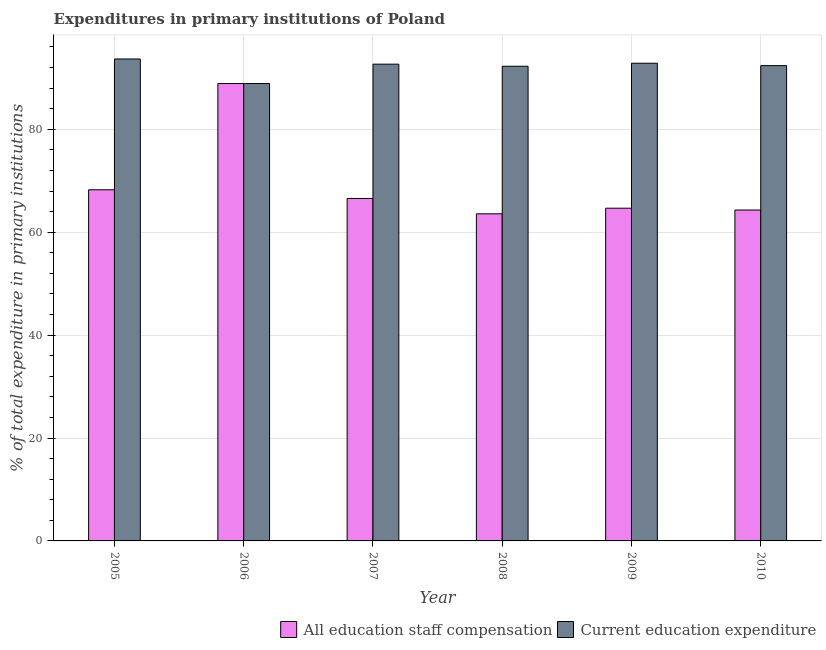Are the number of bars on each tick of the X-axis equal?
Your answer should be very brief. Yes. How many bars are there on the 6th tick from the left?
Offer a very short reply. 2. How many bars are there on the 4th tick from the right?
Provide a succinct answer. 2. What is the label of the 3rd group of bars from the left?
Keep it short and to the point. 2007. What is the expenditure in education in 2009?
Give a very brief answer. 92.84. Across all years, what is the maximum expenditure in staff compensation?
Provide a short and direct response. 88.89. Across all years, what is the minimum expenditure in education?
Give a very brief answer. 88.89. What is the total expenditure in education in the graph?
Give a very brief answer. 552.68. What is the difference between the expenditure in education in 2008 and that in 2010?
Your answer should be compact. -0.12. What is the difference between the expenditure in education in 2009 and the expenditure in staff compensation in 2007?
Make the answer very short. 0.18. What is the average expenditure in staff compensation per year?
Offer a terse response. 69.37. In the year 2005, what is the difference between the expenditure in education and expenditure in staff compensation?
Offer a terse response. 0. In how many years, is the expenditure in staff compensation greater than 24 %?
Offer a terse response. 6. What is the ratio of the expenditure in staff compensation in 2005 to that in 2010?
Offer a terse response. 1.06. Is the expenditure in education in 2005 less than that in 2009?
Offer a very short reply. No. Is the difference between the expenditure in education in 2006 and 2010 greater than the difference between the expenditure in staff compensation in 2006 and 2010?
Give a very brief answer. No. What is the difference between the highest and the second highest expenditure in staff compensation?
Give a very brief answer. 20.65. What is the difference between the highest and the lowest expenditure in staff compensation?
Provide a succinct answer. 25.32. What does the 2nd bar from the left in 2007 represents?
Ensure brevity in your answer.  Current education expenditure. What does the 2nd bar from the right in 2007 represents?
Keep it short and to the point. All education staff compensation. How many years are there in the graph?
Make the answer very short. 6. Does the graph contain any zero values?
Offer a terse response. No. Does the graph contain grids?
Keep it short and to the point. Yes. How are the legend labels stacked?
Offer a very short reply. Horizontal. What is the title of the graph?
Make the answer very short. Expenditures in primary institutions of Poland. Does "Secondary school" appear as one of the legend labels in the graph?
Keep it short and to the point. No. What is the label or title of the X-axis?
Your response must be concise. Year. What is the label or title of the Y-axis?
Make the answer very short. % of total expenditure in primary institutions. What is the % of total expenditure in primary institutions of All education staff compensation in 2005?
Provide a succinct answer. 68.25. What is the % of total expenditure in primary institutions in Current education expenditure in 2005?
Your answer should be compact. 93.67. What is the % of total expenditure in primary institutions in All education staff compensation in 2006?
Provide a succinct answer. 88.89. What is the % of total expenditure in primary institutions in Current education expenditure in 2006?
Offer a terse response. 88.89. What is the % of total expenditure in primary institutions in All education staff compensation in 2007?
Keep it short and to the point. 66.55. What is the % of total expenditure in primary institutions of Current education expenditure in 2007?
Provide a succinct answer. 92.66. What is the % of total expenditure in primary institutions in All education staff compensation in 2008?
Your answer should be compact. 63.57. What is the % of total expenditure in primary institutions in Current education expenditure in 2008?
Make the answer very short. 92.25. What is the % of total expenditure in primary institutions of All education staff compensation in 2009?
Provide a short and direct response. 64.67. What is the % of total expenditure in primary institutions in Current education expenditure in 2009?
Offer a terse response. 92.84. What is the % of total expenditure in primary institutions in All education staff compensation in 2010?
Provide a short and direct response. 64.31. What is the % of total expenditure in primary institutions in Current education expenditure in 2010?
Give a very brief answer. 92.37. Across all years, what is the maximum % of total expenditure in primary institutions of All education staff compensation?
Keep it short and to the point. 88.89. Across all years, what is the maximum % of total expenditure in primary institutions in Current education expenditure?
Provide a short and direct response. 93.67. Across all years, what is the minimum % of total expenditure in primary institutions of All education staff compensation?
Give a very brief answer. 63.57. Across all years, what is the minimum % of total expenditure in primary institutions of Current education expenditure?
Your answer should be very brief. 88.89. What is the total % of total expenditure in primary institutions in All education staff compensation in the graph?
Give a very brief answer. 416.25. What is the total % of total expenditure in primary institutions of Current education expenditure in the graph?
Offer a terse response. 552.68. What is the difference between the % of total expenditure in primary institutions in All education staff compensation in 2005 and that in 2006?
Your response must be concise. -20.65. What is the difference between the % of total expenditure in primary institutions of Current education expenditure in 2005 and that in 2006?
Your answer should be compact. 4.78. What is the difference between the % of total expenditure in primary institutions in All education staff compensation in 2005 and that in 2007?
Your response must be concise. 1.69. What is the difference between the % of total expenditure in primary institutions in Current education expenditure in 2005 and that in 2007?
Offer a very short reply. 1.01. What is the difference between the % of total expenditure in primary institutions in All education staff compensation in 2005 and that in 2008?
Offer a terse response. 4.67. What is the difference between the % of total expenditure in primary institutions of Current education expenditure in 2005 and that in 2008?
Your response must be concise. 1.41. What is the difference between the % of total expenditure in primary institutions of All education staff compensation in 2005 and that in 2009?
Make the answer very short. 3.58. What is the difference between the % of total expenditure in primary institutions of Current education expenditure in 2005 and that in 2009?
Provide a short and direct response. 0.83. What is the difference between the % of total expenditure in primary institutions in All education staff compensation in 2005 and that in 2010?
Your answer should be compact. 3.93. What is the difference between the % of total expenditure in primary institutions in Current education expenditure in 2005 and that in 2010?
Your answer should be very brief. 1.3. What is the difference between the % of total expenditure in primary institutions of All education staff compensation in 2006 and that in 2007?
Give a very brief answer. 22.34. What is the difference between the % of total expenditure in primary institutions of Current education expenditure in 2006 and that in 2007?
Provide a short and direct response. -3.76. What is the difference between the % of total expenditure in primary institutions of All education staff compensation in 2006 and that in 2008?
Give a very brief answer. 25.32. What is the difference between the % of total expenditure in primary institutions of Current education expenditure in 2006 and that in 2008?
Give a very brief answer. -3.36. What is the difference between the % of total expenditure in primary institutions of All education staff compensation in 2006 and that in 2009?
Offer a terse response. 24.23. What is the difference between the % of total expenditure in primary institutions in Current education expenditure in 2006 and that in 2009?
Your answer should be compact. -3.95. What is the difference between the % of total expenditure in primary institutions of All education staff compensation in 2006 and that in 2010?
Your response must be concise. 24.58. What is the difference between the % of total expenditure in primary institutions in Current education expenditure in 2006 and that in 2010?
Your answer should be very brief. -3.48. What is the difference between the % of total expenditure in primary institutions of All education staff compensation in 2007 and that in 2008?
Your response must be concise. 2.98. What is the difference between the % of total expenditure in primary institutions in Current education expenditure in 2007 and that in 2008?
Provide a succinct answer. 0.4. What is the difference between the % of total expenditure in primary institutions in All education staff compensation in 2007 and that in 2009?
Your answer should be compact. 1.89. What is the difference between the % of total expenditure in primary institutions in Current education expenditure in 2007 and that in 2009?
Provide a succinct answer. -0.18. What is the difference between the % of total expenditure in primary institutions of All education staff compensation in 2007 and that in 2010?
Ensure brevity in your answer.  2.24. What is the difference between the % of total expenditure in primary institutions of Current education expenditure in 2007 and that in 2010?
Offer a terse response. 0.28. What is the difference between the % of total expenditure in primary institutions in All education staff compensation in 2008 and that in 2009?
Provide a short and direct response. -1.09. What is the difference between the % of total expenditure in primary institutions of Current education expenditure in 2008 and that in 2009?
Your answer should be compact. -0.58. What is the difference between the % of total expenditure in primary institutions of All education staff compensation in 2008 and that in 2010?
Provide a short and direct response. -0.74. What is the difference between the % of total expenditure in primary institutions of Current education expenditure in 2008 and that in 2010?
Make the answer very short. -0.12. What is the difference between the % of total expenditure in primary institutions in All education staff compensation in 2009 and that in 2010?
Keep it short and to the point. 0.36. What is the difference between the % of total expenditure in primary institutions in Current education expenditure in 2009 and that in 2010?
Give a very brief answer. 0.47. What is the difference between the % of total expenditure in primary institutions in All education staff compensation in 2005 and the % of total expenditure in primary institutions in Current education expenditure in 2006?
Offer a very short reply. -20.65. What is the difference between the % of total expenditure in primary institutions in All education staff compensation in 2005 and the % of total expenditure in primary institutions in Current education expenditure in 2007?
Give a very brief answer. -24.41. What is the difference between the % of total expenditure in primary institutions of All education staff compensation in 2005 and the % of total expenditure in primary institutions of Current education expenditure in 2008?
Make the answer very short. -24.01. What is the difference between the % of total expenditure in primary institutions of All education staff compensation in 2005 and the % of total expenditure in primary institutions of Current education expenditure in 2009?
Offer a terse response. -24.59. What is the difference between the % of total expenditure in primary institutions of All education staff compensation in 2005 and the % of total expenditure in primary institutions of Current education expenditure in 2010?
Provide a short and direct response. -24.13. What is the difference between the % of total expenditure in primary institutions of All education staff compensation in 2006 and the % of total expenditure in primary institutions of Current education expenditure in 2007?
Ensure brevity in your answer.  -3.76. What is the difference between the % of total expenditure in primary institutions of All education staff compensation in 2006 and the % of total expenditure in primary institutions of Current education expenditure in 2008?
Keep it short and to the point. -3.36. What is the difference between the % of total expenditure in primary institutions in All education staff compensation in 2006 and the % of total expenditure in primary institutions in Current education expenditure in 2009?
Your answer should be compact. -3.95. What is the difference between the % of total expenditure in primary institutions of All education staff compensation in 2006 and the % of total expenditure in primary institutions of Current education expenditure in 2010?
Your response must be concise. -3.48. What is the difference between the % of total expenditure in primary institutions of All education staff compensation in 2007 and the % of total expenditure in primary institutions of Current education expenditure in 2008?
Offer a terse response. -25.7. What is the difference between the % of total expenditure in primary institutions in All education staff compensation in 2007 and the % of total expenditure in primary institutions in Current education expenditure in 2009?
Your answer should be very brief. -26.28. What is the difference between the % of total expenditure in primary institutions of All education staff compensation in 2007 and the % of total expenditure in primary institutions of Current education expenditure in 2010?
Provide a succinct answer. -25.82. What is the difference between the % of total expenditure in primary institutions in All education staff compensation in 2008 and the % of total expenditure in primary institutions in Current education expenditure in 2009?
Offer a very short reply. -29.26. What is the difference between the % of total expenditure in primary institutions of All education staff compensation in 2008 and the % of total expenditure in primary institutions of Current education expenditure in 2010?
Offer a terse response. -28.8. What is the difference between the % of total expenditure in primary institutions in All education staff compensation in 2009 and the % of total expenditure in primary institutions in Current education expenditure in 2010?
Provide a short and direct response. -27.71. What is the average % of total expenditure in primary institutions in All education staff compensation per year?
Make the answer very short. 69.37. What is the average % of total expenditure in primary institutions in Current education expenditure per year?
Provide a short and direct response. 92.11. In the year 2005, what is the difference between the % of total expenditure in primary institutions of All education staff compensation and % of total expenditure in primary institutions of Current education expenditure?
Your answer should be very brief. -25.42. In the year 2006, what is the difference between the % of total expenditure in primary institutions of All education staff compensation and % of total expenditure in primary institutions of Current education expenditure?
Your response must be concise. 0. In the year 2007, what is the difference between the % of total expenditure in primary institutions in All education staff compensation and % of total expenditure in primary institutions in Current education expenditure?
Keep it short and to the point. -26.1. In the year 2008, what is the difference between the % of total expenditure in primary institutions of All education staff compensation and % of total expenditure in primary institutions of Current education expenditure?
Your response must be concise. -28.68. In the year 2009, what is the difference between the % of total expenditure in primary institutions of All education staff compensation and % of total expenditure in primary institutions of Current education expenditure?
Offer a very short reply. -28.17. In the year 2010, what is the difference between the % of total expenditure in primary institutions of All education staff compensation and % of total expenditure in primary institutions of Current education expenditure?
Your answer should be very brief. -28.06. What is the ratio of the % of total expenditure in primary institutions of All education staff compensation in 2005 to that in 2006?
Make the answer very short. 0.77. What is the ratio of the % of total expenditure in primary institutions of Current education expenditure in 2005 to that in 2006?
Give a very brief answer. 1.05. What is the ratio of the % of total expenditure in primary institutions in All education staff compensation in 2005 to that in 2007?
Offer a terse response. 1.03. What is the ratio of the % of total expenditure in primary institutions in Current education expenditure in 2005 to that in 2007?
Provide a short and direct response. 1.01. What is the ratio of the % of total expenditure in primary institutions in All education staff compensation in 2005 to that in 2008?
Your answer should be very brief. 1.07. What is the ratio of the % of total expenditure in primary institutions in Current education expenditure in 2005 to that in 2008?
Your answer should be very brief. 1.02. What is the ratio of the % of total expenditure in primary institutions in All education staff compensation in 2005 to that in 2009?
Give a very brief answer. 1.06. What is the ratio of the % of total expenditure in primary institutions of Current education expenditure in 2005 to that in 2009?
Keep it short and to the point. 1.01. What is the ratio of the % of total expenditure in primary institutions in All education staff compensation in 2005 to that in 2010?
Your answer should be very brief. 1.06. What is the ratio of the % of total expenditure in primary institutions in Current education expenditure in 2005 to that in 2010?
Your answer should be very brief. 1.01. What is the ratio of the % of total expenditure in primary institutions of All education staff compensation in 2006 to that in 2007?
Give a very brief answer. 1.34. What is the ratio of the % of total expenditure in primary institutions in Current education expenditure in 2006 to that in 2007?
Offer a terse response. 0.96. What is the ratio of the % of total expenditure in primary institutions of All education staff compensation in 2006 to that in 2008?
Offer a terse response. 1.4. What is the ratio of the % of total expenditure in primary institutions of Current education expenditure in 2006 to that in 2008?
Your response must be concise. 0.96. What is the ratio of the % of total expenditure in primary institutions of All education staff compensation in 2006 to that in 2009?
Keep it short and to the point. 1.37. What is the ratio of the % of total expenditure in primary institutions in Current education expenditure in 2006 to that in 2009?
Make the answer very short. 0.96. What is the ratio of the % of total expenditure in primary institutions of All education staff compensation in 2006 to that in 2010?
Provide a short and direct response. 1.38. What is the ratio of the % of total expenditure in primary institutions in Current education expenditure in 2006 to that in 2010?
Provide a succinct answer. 0.96. What is the ratio of the % of total expenditure in primary institutions of All education staff compensation in 2007 to that in 2008?
Provide a short and direct response. 1.05. What is the ratio of the % of total expenditure in primary institutions of Current education expenditure in 2007 to that in 2008?
Give a very brief answer. 1. What is the ratio of the % of total expenditure in primary institutions in All education staff compensation in 2007 to that in 2009?
Your answer should be compact. 1.03. What is the ratio of the % of total expenditure in primary institutions in All education staff compensation in 2007 to that in 2010?
Your answer should be very brief. 1.03. What is the ratio of the % of total expenditure in primary institutions in Current education expenditure in 2007 to that in 2010?
Your answer should be very brief. 1. What is the ratio of the % of total expenditure in primary institutions of All education staff compensation in 2008 to that in 2009?
Your answer should be very brief. 0.98. What is the ratio of the % of total expenditure in primary institutions of Current education expenditure in 2008 to that in 2009?
Offer a very short reply. 0.99. What is the ratio of the % of total expenditure in primary institutions in Current education expenditure in 2008 to that in 2010?
Give a very brief answer. 1. What is the ratio of the % of total expenditure in primary institutions of All education staff compensation in 2009 to that in 2010?
Offer a terse response. 1.01. What is the difference between the highest and the second highest % of total expenditure in primary institutions in All education staff compensation?
Make the answer very short. 20.65. What is the difference between the highest and the second highest % of total expenditure in primary institutions in Current education expenditure?
Your answer should be compact. 0.83. What is the difference between the highest and the lowest % of total expenditure in primary institutions in All education staff compensation?
Ensure brevity in your answer.  25.32. What is the difference between the highest and the lowest % of total expenditure in primary institutions of Current education expenditure?
Your response must be concise. 4.78. 